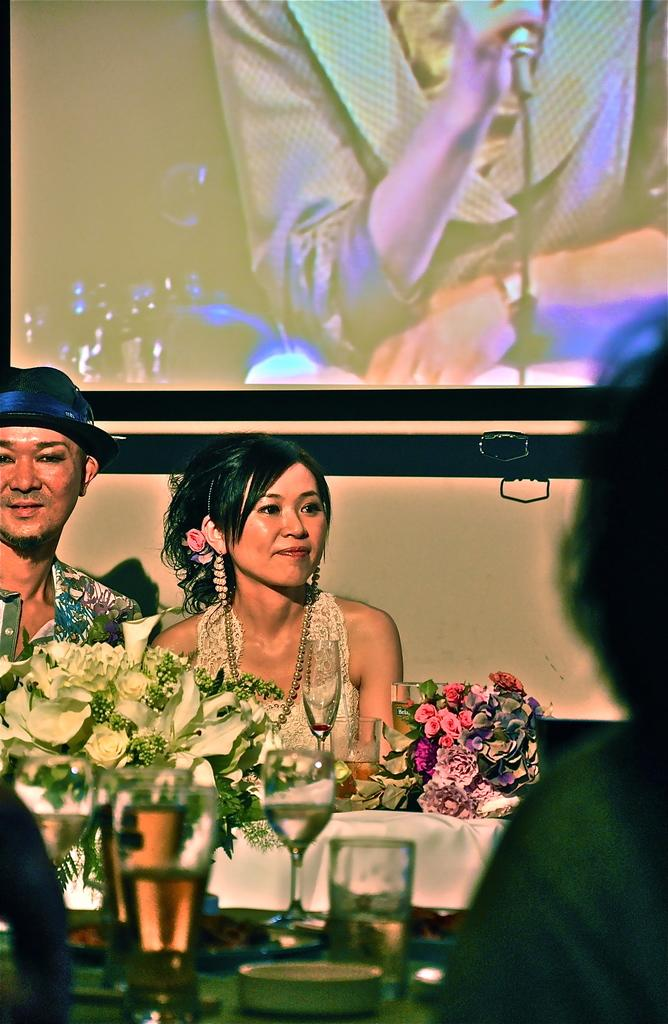How many people are present in the image? There are two persons sitting in the image. What is the facial expression of the persons? The persons are smiling. What is located in the image besides the persons? There is a table in the image. What objects can be seen on the table? There are glasses on the table. What is visible in the background of the image? There is a wall in the background of the image. What is on the wall? There is a screen on the wall. What type of dress is the visitor wearing in the image? There is no visitor present in the image, and therefore no dress can be observed. What scientific experiment is being conducted in the image? There is no scientific experiment being conducted in the image; it features two persons sitting and smiling. 